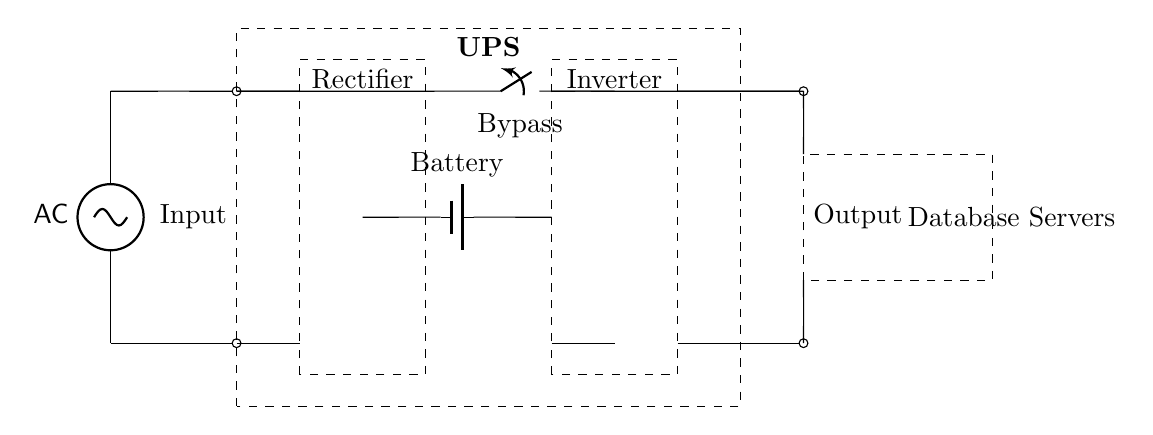What components are present in this UPS circuit? The diagram shows an AC power supply, a UPS block, a rectifier, a battery, an inverter, output connections to database servers, and a bypass switch.
Answer: AC power supply, UPS, rectifier, battery, inverter, output, bypass switch What is the role of the battery in this circuit? The battery stores energy to provide backup power during a power outage, ensuring that the database servers remain operational when the AC power is unavailable.
Answer: Backup power How many main functional blocks are in the UPS circuit? There are three functional blocks: rectifier, battery, and inverter, in addition to the UPS block that includes the bypass switch.
Answer: Three What is the direction of the current flow during normal operation? The current flows from the AC power supply through the rectifier to charge the battery and supply power to the inverter, which then powers the database servers, following a specific path as shown in the circuit.
Answer: From AC supply to rectifier to battery to inverter to output How does the bypass switch function in this circuit? The bypass switch allows direct connection from the AC power supply to the output (database servers) during maintenance or if the UPS is not in use, bypassing the rectifier, battery, and inverter.
Answer: Direct connection What type of circuit is represented in this diagram? This is a uninterruptible power supply (UPS) circuit specifically designed for providing continuous power to database servers, protecting them from power disruptions.
Answer: Uninterruptible power supply 